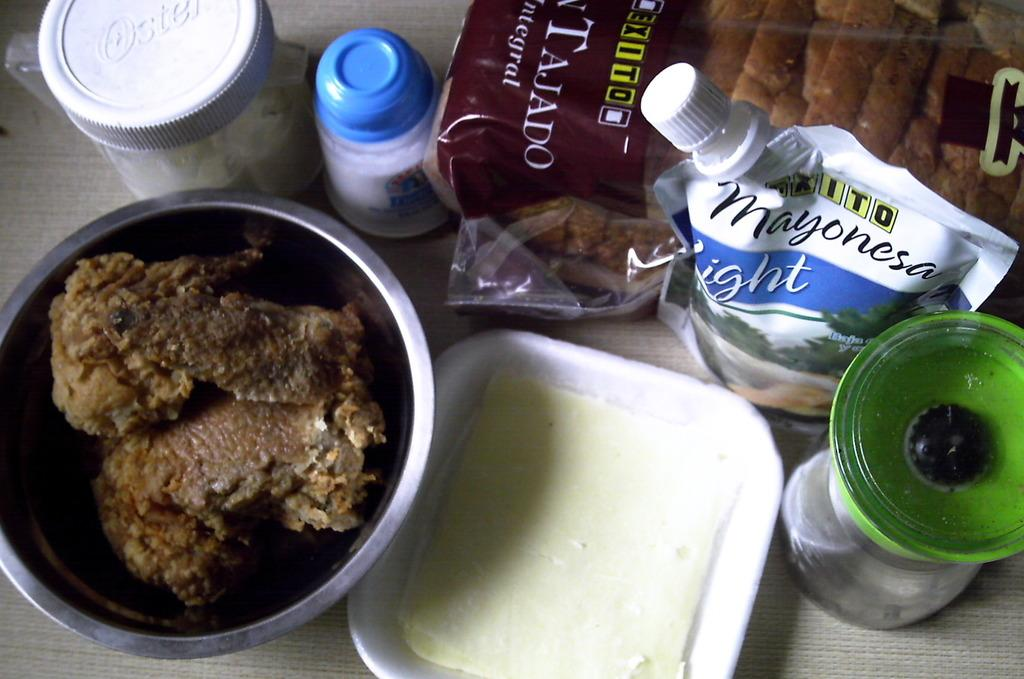Provide a one-sentence caption for the provided image. Different food items including bread and mayo sit on a table. 